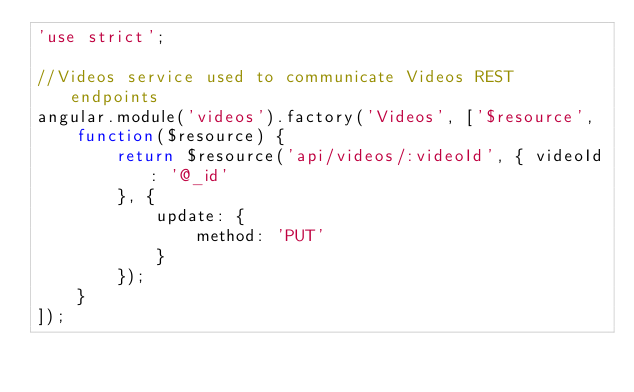<code> <loc_0><loc_0><loc_500><loc_500><_JavaScript_>'use strict';

//Videos service used to communicate Videos REST endpoints
angular.module('videos').factory('Videos', ['$resource',
	function($resource) {
		return $resource('api/videos/:videoId', { videoId: '@_id'
		}, {
			update: {
				method: 'PUT'
			}
		});
	}
]);</code> 